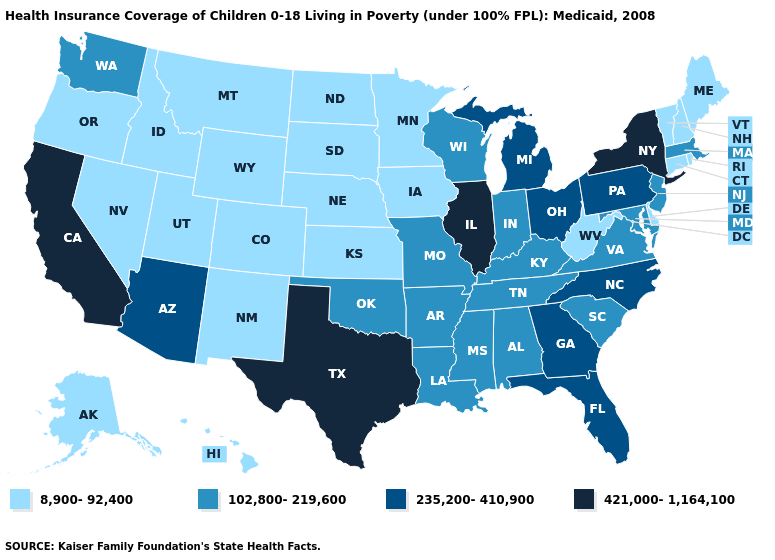How many symbols are there in the legend?
Concise answer only. 4. Does Washington have the lowest value in the West?
Give a very brief answer. No. Does the first symbol in the legend represent the smallest category?
Short answer required. Yes. Among the states that border Washington , which have the highest value?
Quick response, please. Idaho, Oregon. What is the value of Florida?
Give a very brief answer. 235,200-410,900. Name the states that have a value in the range 8,900-92,400?
Keep it brief. Alaska, Colorado, Connecticut, Delaware, Hawaii, Idaho, Iowa, Kansas, Maine, Minnesota, Montana, Nebraska, Nevada, New Hampshire, New Mexico, North Dakota, Oregon, Rhode Island, South Dakota, Utah, Vermont, West Virginia, Wyoming. Name the states that have a value in the range 235,200-410,900?
Be succinct. Arizona, Florida, Georgia, Michigan, North Carolina, Ohio, Pennsylvania. Which states have the lowest value in the USA?
Short answer required. Alaska, Colorado, Connecticut, Delaware, Hawaii, Idaho, Iowa, Kansas, Maine, Minnesota, Montana, Nebraska, Nevada, New Hampshire, New Mexico, North Dakota, Oregon, Rhode Island, South Dakota, Utah, Vermont, West Virginia, Wyoming. What is the highest value in the West ?
Be succinct. 421,000-1,164,100. What is the value of Wisconsin?
Quick response, please. 102,800-219,600. What is the value of Texas?
Answer briefly. 421,000-1,164,100. Name the states that have a value in the range 421,000-1,164,100?
Be succinct. California, Illinois, New York, Texas. Name the states that have a value in the range 235,200-410,900?
Concise answer only. Arizona, Florida, Georgia, Michigan, North Carolina, Ohio, Pennsylvania. 